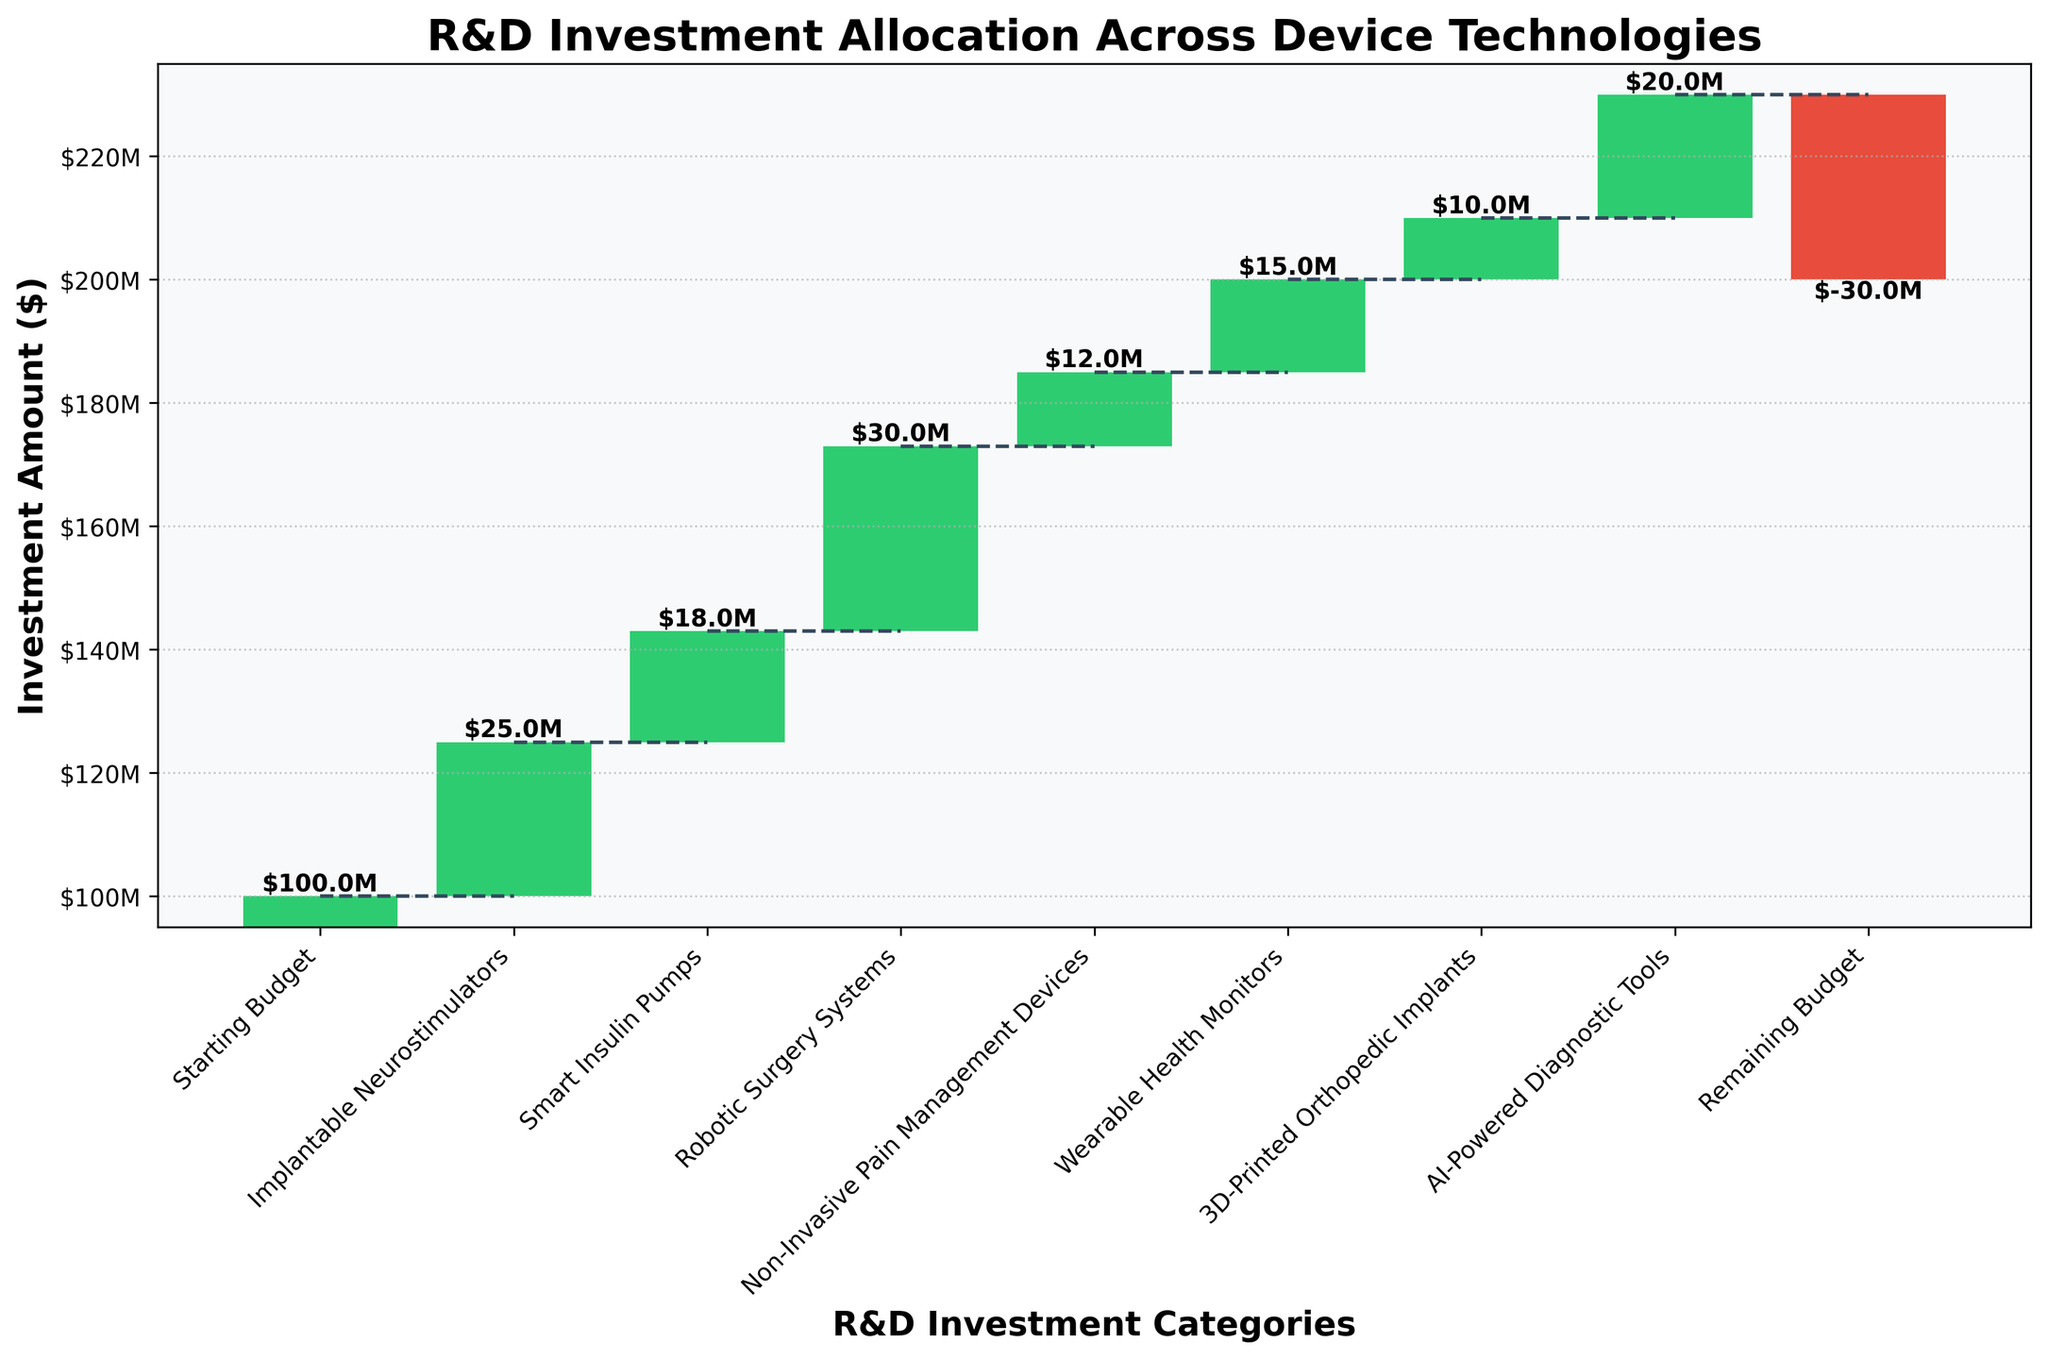What's the highest investment allocation among the device technologies? To find the highest investment allocation, look for the device with the largest bar. The Robotic Surgery Systems has the tallest bar representing a value of $30 million.
Answer: $30 million What's the total investment sum across all device technologies (excluding the remaining budget)? Add the investment amounts for each device technology: (25M for Implantable Neurostimulators + 18M for Smart Insulin Pumps + 30M for Robotic Surgery Systems + 12M for Non-Invasive Pain Management Devices + 15M for Wearable Health Monitors + 10M for 3D-Printed Orthopedic Implants + 20M for AI-Powered Diagnostic Tools) = $130 million.
Answer: $130 million How does the investment in Smart Insulin Pumps compare to Wearable Health Monitors? The investment in Smart Insulin Pumps is $18 million, and for Wearable Health Monitors, it is $15 million. Therefore, Smart Insulin Pumps received a higher investment by $3 million.
Answer: $3 million more What is the value of the remaining budget? The remaining budget, as indicated by the last entry in the figure, is -$30 million. This is shown by the negative value at the end of the waterfall chart.
Answer: -$30 million If the investment in AI-Powered Diagnostic Tools were doubled, what would be the new remaining budget? The original investment for AI-Powered Diagnostic Tools is $20 million. Doubling it results in $40 million. The original remaining budget is -$30 million, so adding an additional $20 million from the increased investment would change it to (-$30 million - $20 million) = -$50 million.
Answer: -$50 million Which device technology has the least investment? The smallest bar represents the least investment. Here, the 3D-Printed Orthopedic Implants has a bar representing a value of $10 million.
Answer: $10 million What is the cumulative investment value just before accounting for the remaining budget? The cumulative value before the remaining budget is the sum of all investments: Starting from Initial budget $100 million and adding up investments (25M + 18M + 30M + 12M + 15M + 10M + 20M). The last positive cumulative value before subtracting the remaining budget is $130 million.
Answer: $130 million How much larger is the investment in Robotic Surgery Systems compared to Implantable Neurostimulators? The investment amount for Robotic Surgery Systems is $30 million and for Implantable Neurostimulators is $25 million. The difference is (30M - 25M) = $5 million.
Answer: $5 million If an additional $5 million were allocated to Non-Invasive Pain Management Devices, what would be the new cumulative total after this addition? The current investment is $12 million. Adding $5 million will make it $17 million. The original cumulative investment including Non-Invasive Pain Management Devices was $85 million. Adding the new amount (17M instead of 12M) makes it $90 million.
Answer: $90 million 